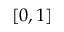Convert formula to latex. <formula><loc_0><loc_0><loc_500><loc_500>[ 0 , 1 ]</formula> 